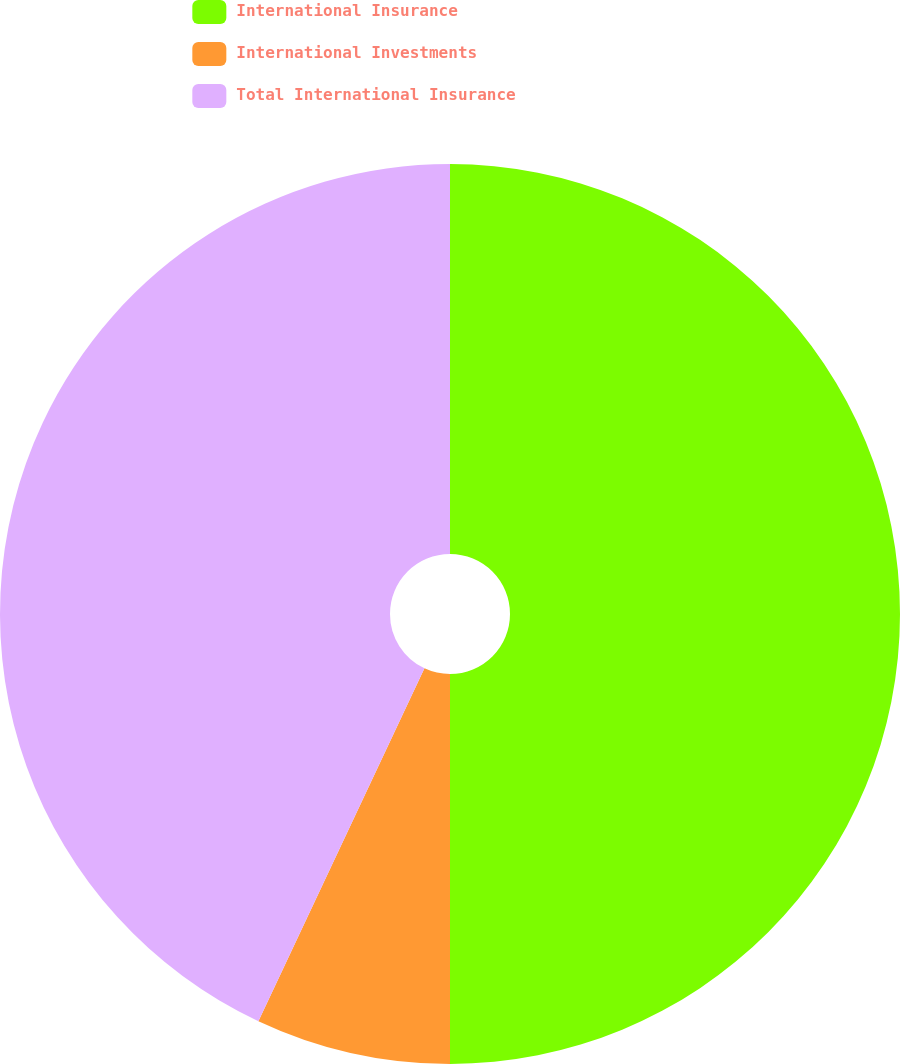Convert chart to OTSL. <chart><loc_0><loc_0><loc_500><loc_500><pie_chart><fcel>International Insurance<fcel>International Investments<fcel>Total International Insurance<nl><fcel>50.0%<fcel>7.0%<fcel>43.0%<nl></chart> 